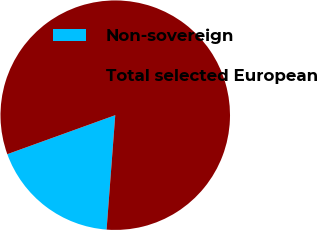<chart> <loc_0><loc_0><loc_500><loc_500><pie_chart><fcel>Non-sovereign<fcel>Total selected European<nl><fcel>18.28%<fcel>81.72%<nl></chart> 